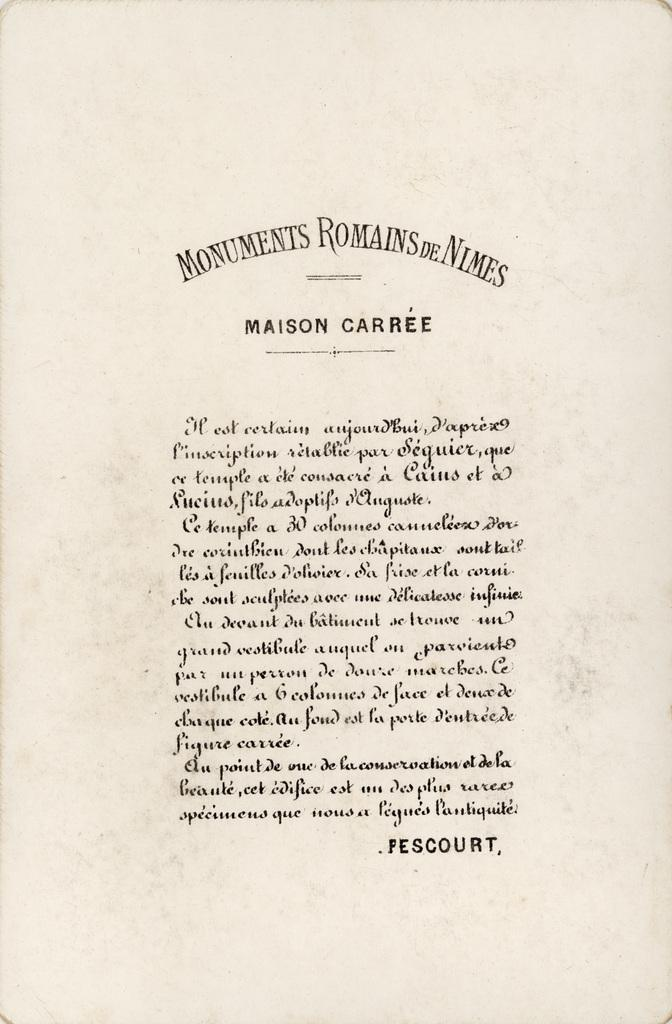Provide a one-sentence caption for the provided image. a old canvas paper with the title MONUMENTS ROMAINS DE NIMES at the top and MAISON CARREE after it, the rest unreadable in another language.. 